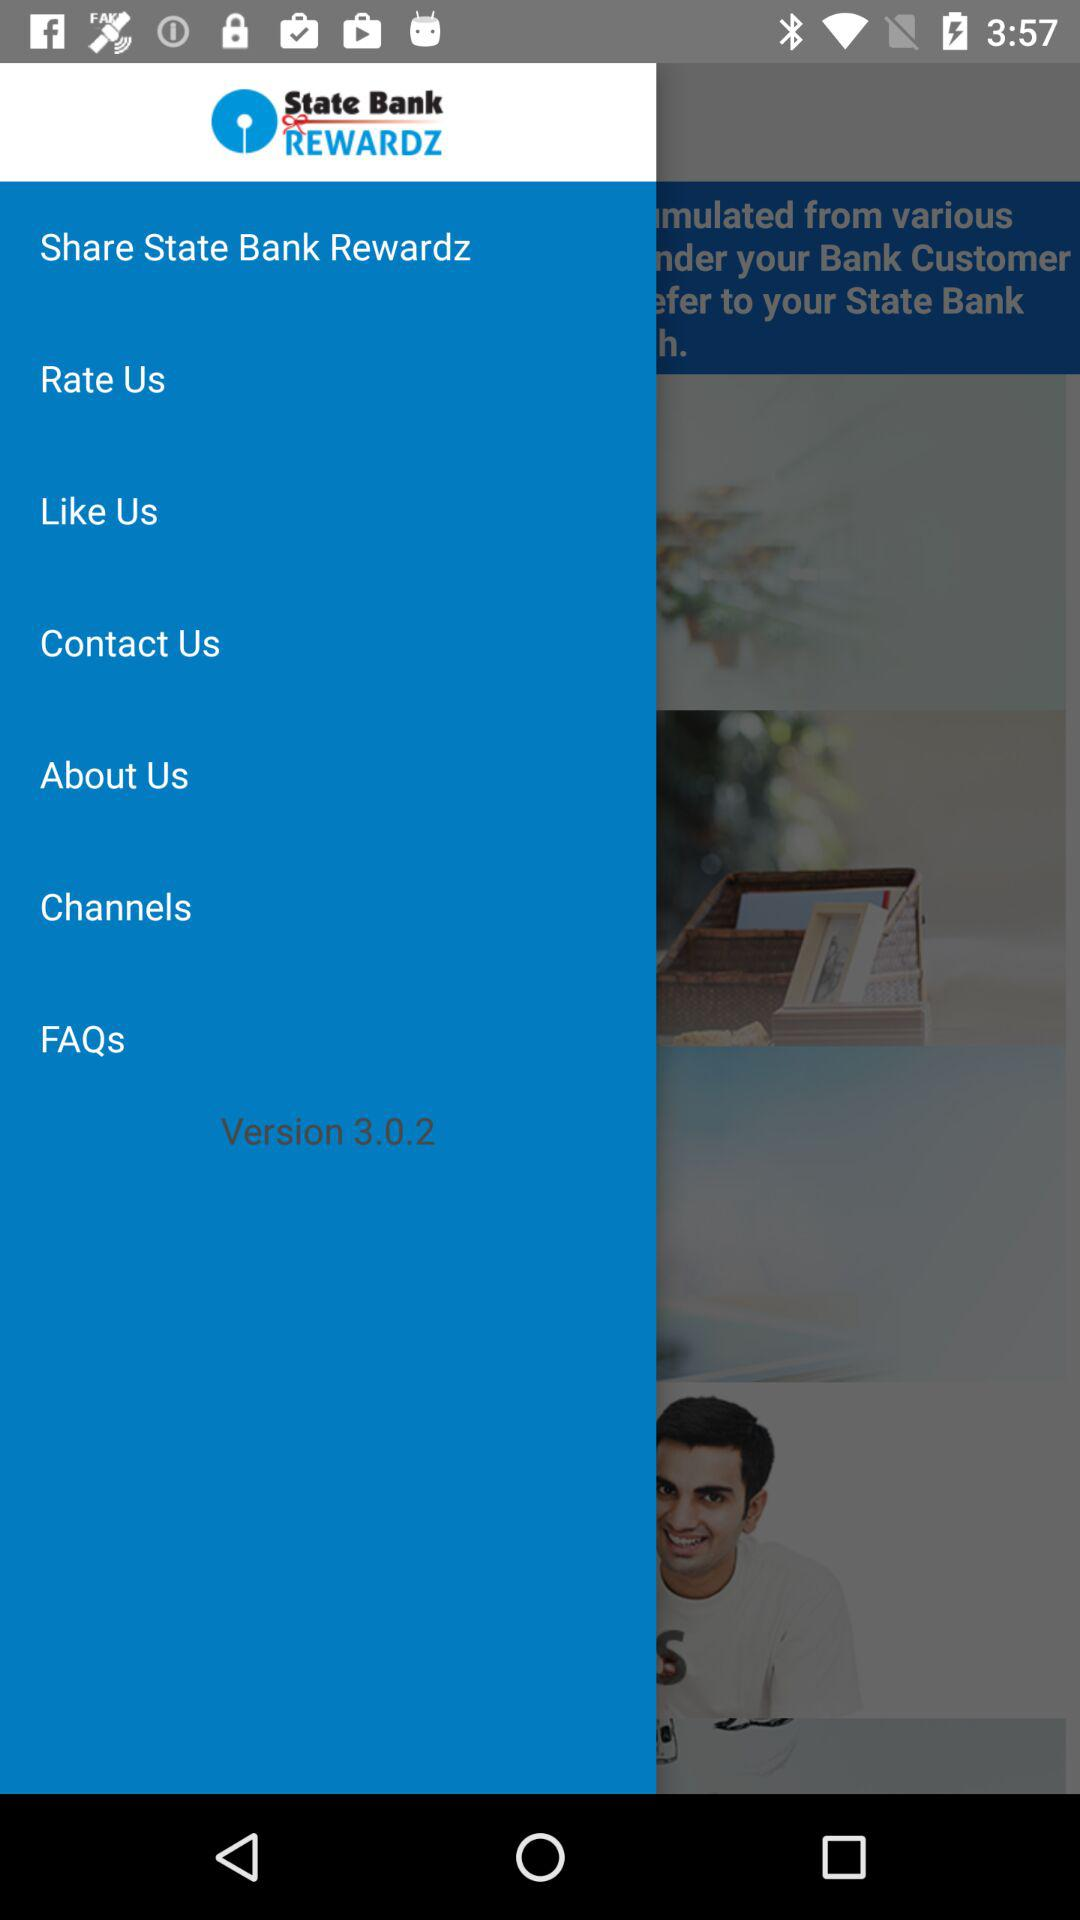What is the name of the application? The name of the application is "State Bank Rewardz". 